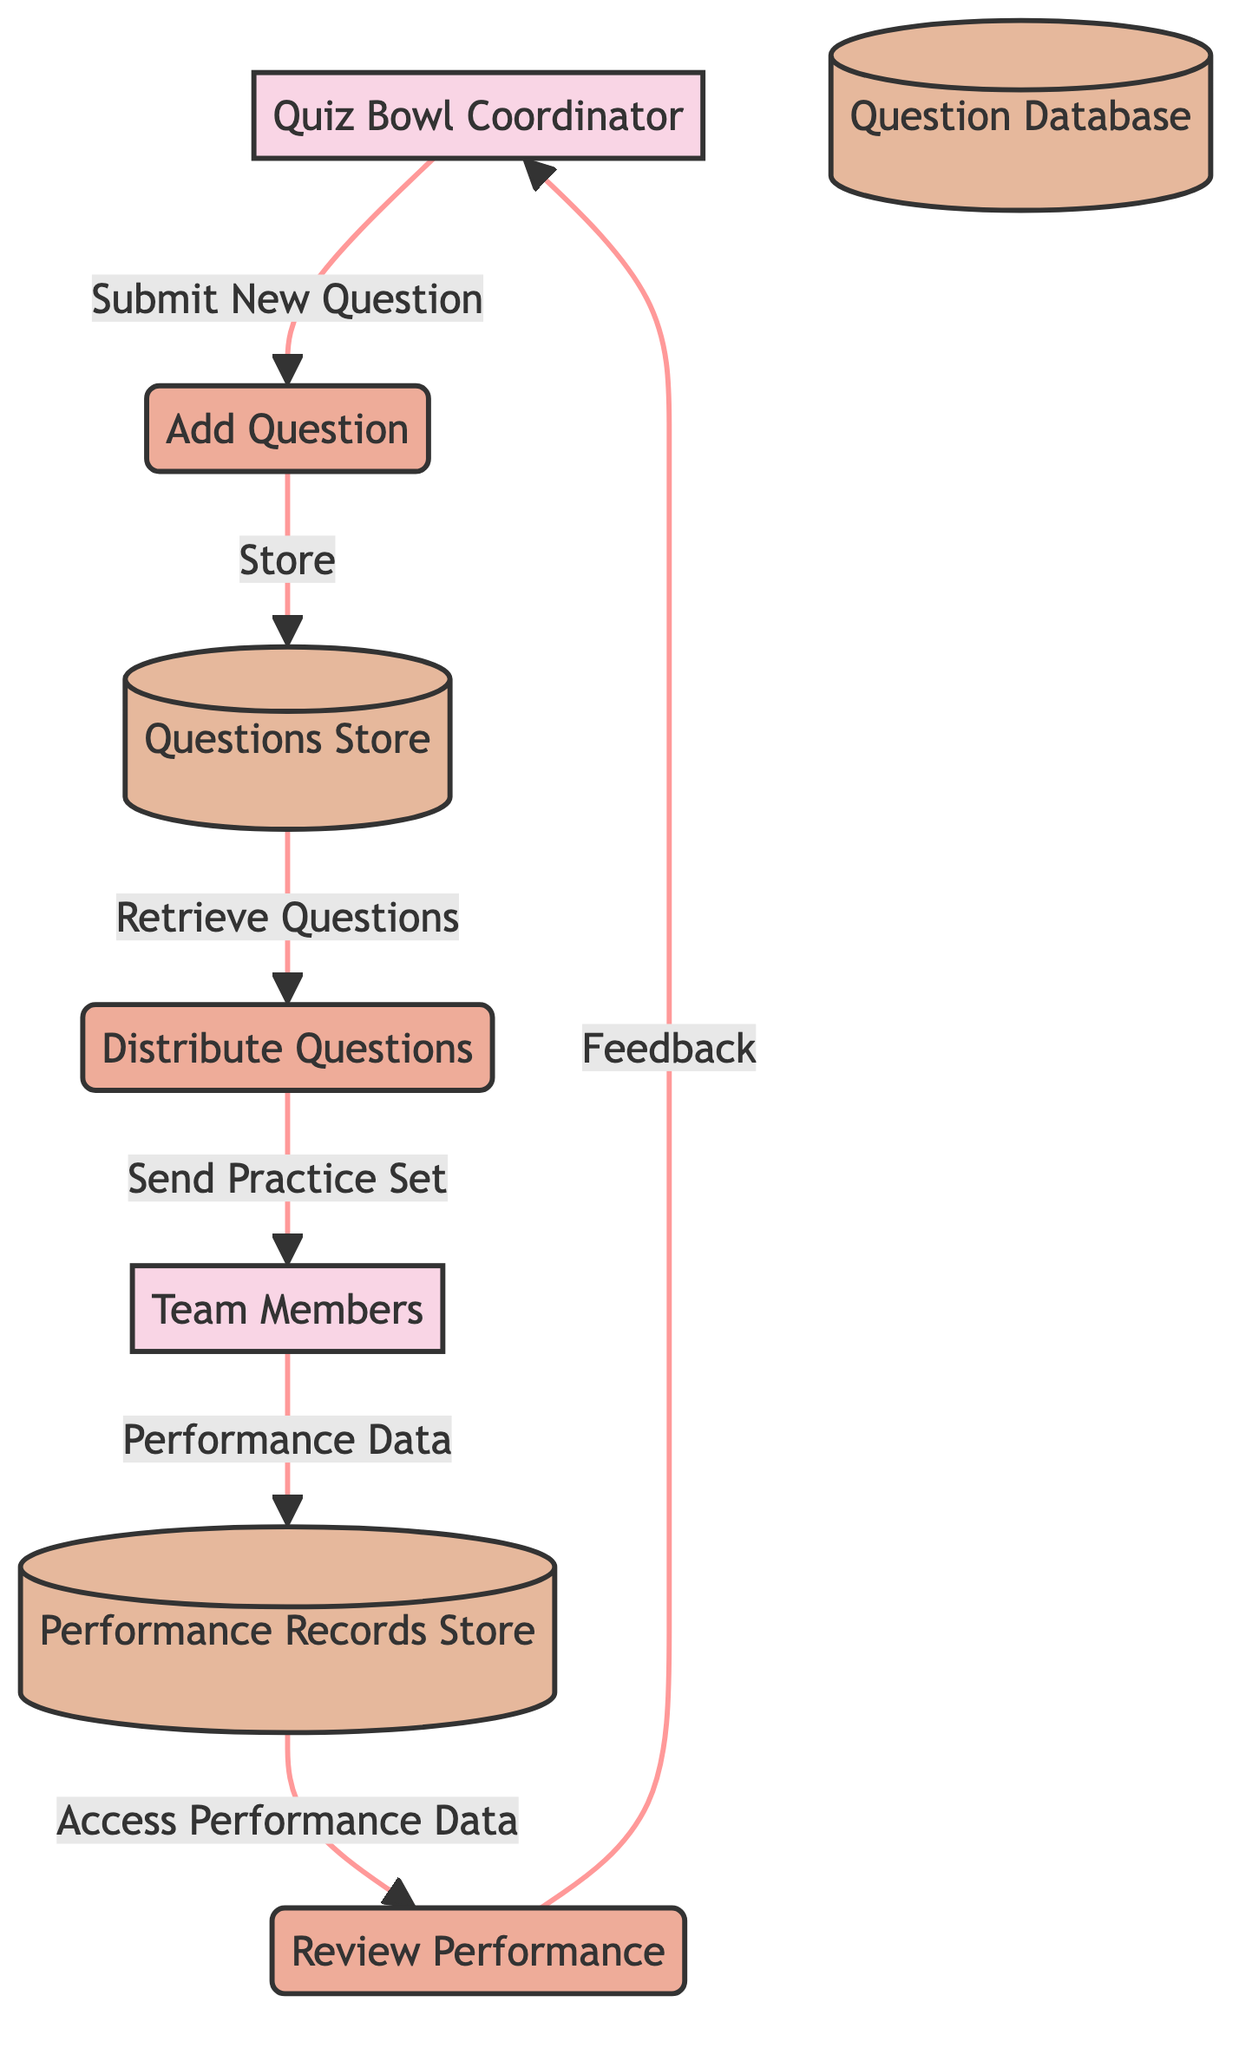What entity is responsible for overseeing the distribution of quiz bowl questions? The diagram clearly indicates that the "Quiz Bowl Coordinator" is labeled as the entity responsible for overseeing the distribution of quiz bowl questions. This is evident from the description linked to the corresponding entity node.
Answer: Quiz Bowl Coordinator How many processes are represented in the diagram? By counting the process nodes in the diagram, we find three distinct processes: "Add Question," "Distribute Questions," and "Review Performance." This makes the total number of processes three.
Answer: 3 What flow is utilized to submit new questions to the store? The flow labeled "Submit New Question" originates from the "Quiz Bowl Coordinator" and points towards the "Questions Store," indicating this is the method used for submitting new questions.
Answer: Submit New Question Which data store holds the performance records of team members? The diagram identifies "Performance Records Store" as the data store that is responsible for holding records of team members' performance. This is clarified in the description associated with that data store node.
Answer: Performance Records Store Who receives the tailored set of questions for practice? The "Team Members" entity is the designated recipient of the tailored set of questions, received through the "Send Practice Set" flow coming from the "Questions Store."
Answer: Team Members What is the last action taken by the Quiz Bowl Coordinator in the process? The last action indicated in the process for the Quiz Bowl Coordinator is "Feedback," stemming from their review of performance data accessed from the "Performance Records Store." Thus, the final action is providing feedback.
Answer: Feedback How does the team members’ performance data reach the performance records store? The flow labeled "Performance Data" comes from the "Team Members" and directs into the "Performance Records Store," showing how their performance data is recorded. This defining flow explains the path of the performance data.
Answer: Performance Data What is the function of the process labeled 'Distribute Questions'? The "Distribute Questions" process functions to manage the distribution of specific practice question sets to the "Team Members," as indicated by the flow "Send Practice Set" from the "Questions Store."
Answer: Distribute Questions Explain the direction of the flow from the Questions Store to Team Members. The flow from the "Questions Store" to "Team Members" is labeled "Send Practice Set," demonstrating that the flow direction indicates that specific sets of questions are sent from the storage to the members for their practice.
Answer: Send Practice Set 